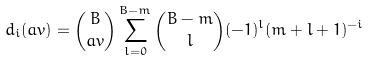<formula> <loc_0><loc_0><loc_500><loc_500>d _ { i } ( \real a v ) = { B \choose \real a v } \sum _ { l = 0 } ^ { B - m } { B - m \choose l } ( - 1 ) ^ { l } ( m + l + 1 ) ^ { - i }</formula> 